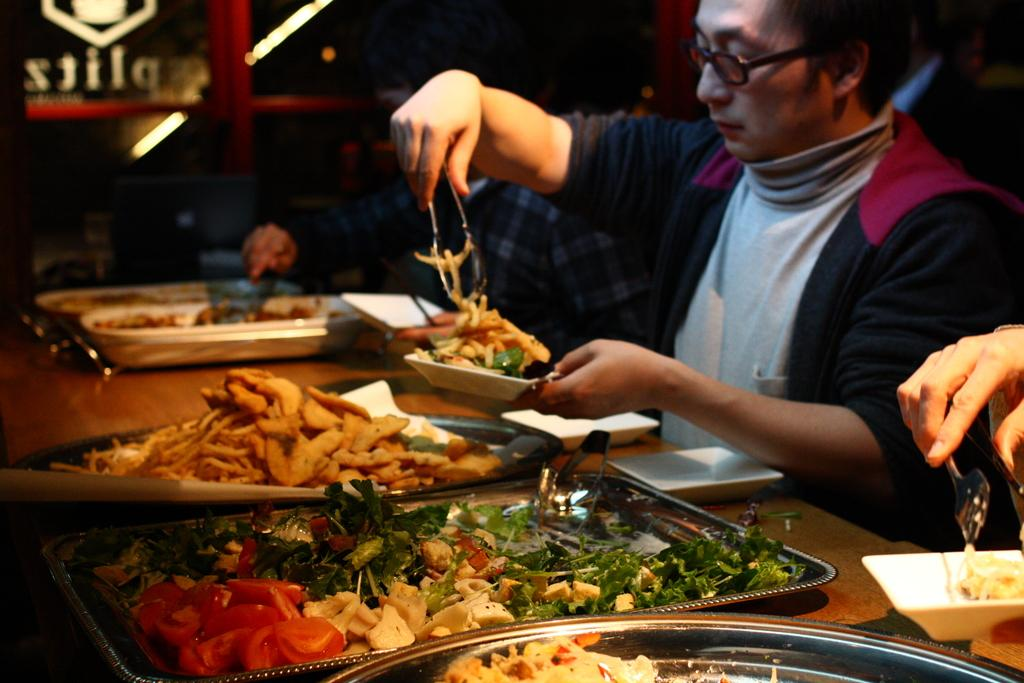How many people are sitting in the image? There are two people sitting on chairs in the image. What is present in the image besides the people? There is a table in the image. What can be found on the table? There are plates and trays on the table. What type of items are on the table? There are different types of food items on the table. Can you see a door leading to the seashore in the image? There is no door or seashore present in the image. What type of reward is being given to the people in the image? There is no reward being given in the image; it simply shows two people sitting at a table with food items. 